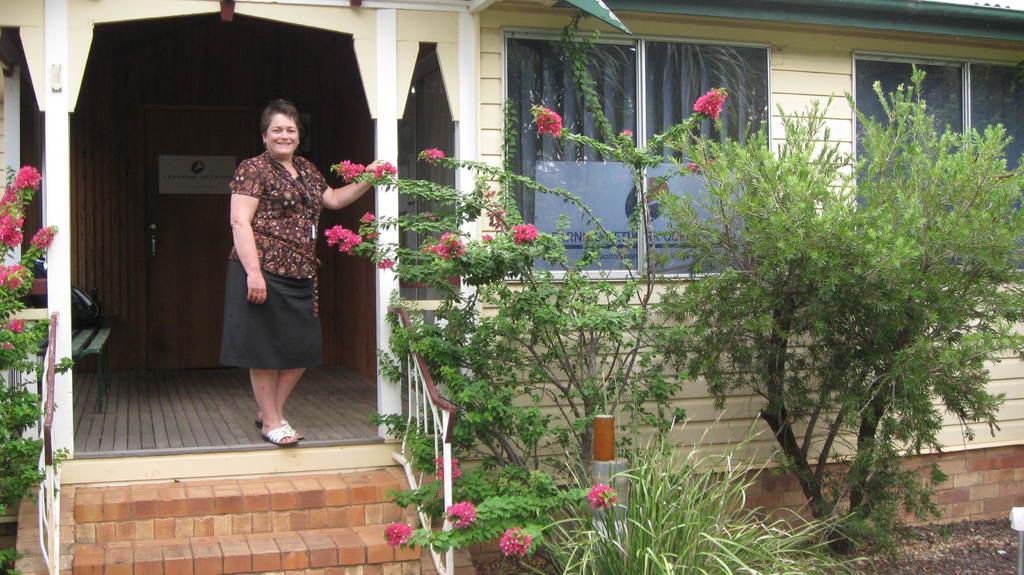Describe this image in one or two sentences. In this picture we can see some grass on the ground. There are a few flowers and plants on the path. We can see a woman holding a flower and smiling. There is a green object in the building. We can see a poster, windows and a curtain in the building. 